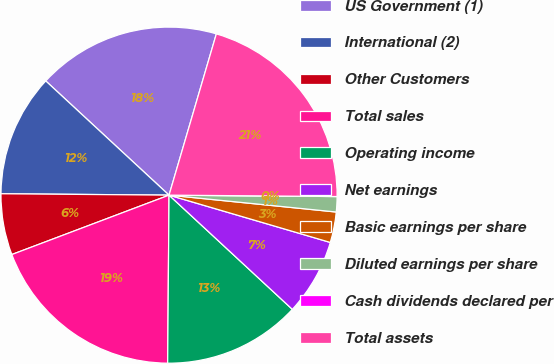Convert chart to OTSL. <chart><loc_0><loc_0><loc_500><loc_500><pie_chart><fcel>US Government (1)<fcel>International (2)<fcel>Other Customers<fcel>Total sales<fcel>Operating income<fcel>Net earnings<fcel>Basic earnings per share<fcel>Diluted earnings per share<fcel>Cash dividends declared per<fcel>Total assets<nl><fcel>17.65%<fcel>11.76%<fcel>5.88%<fcel>19.12%<fcel>13.24%<fcel>7.35%<fcel>2.94%<fcel>1.47%<fcel>0.0%<fcel>20.59%<nl></chart> 